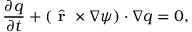Convert formula to latex. <formula><loc_0><loc_0><loc_500><loc_500>\frac { \partial q } { \partial t } + ( \hat { r } \times \nabla \psi ) \cdot \nabla q = 0 ,</formula> 